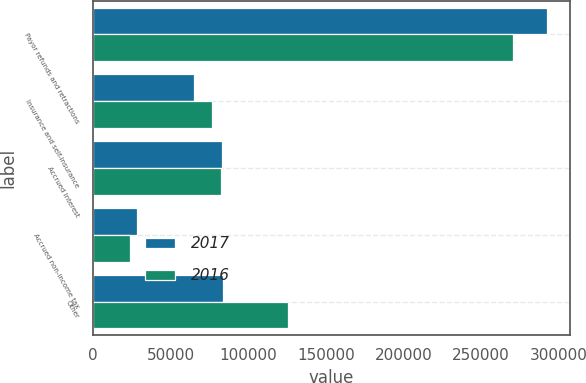Convert chart. <chart><loc_0><loc_0><loc_500><loc_500><stacked_bar_chart><ecel><fcel>Payor refunds and retractions<fcel>Insurance and self-insurance<fcel>Accrued interest<fcel>Accrued non-income tax<fcel>Other<nl><fcel>2017<fcel>292370<fcel>64924<fcel>83362<fcel>28317<fcel>83689<nl><fcel>2016<fcel>270298<fcel>76857<fcel>82234<fcel>23643<fcel>125860<nl></chart> 